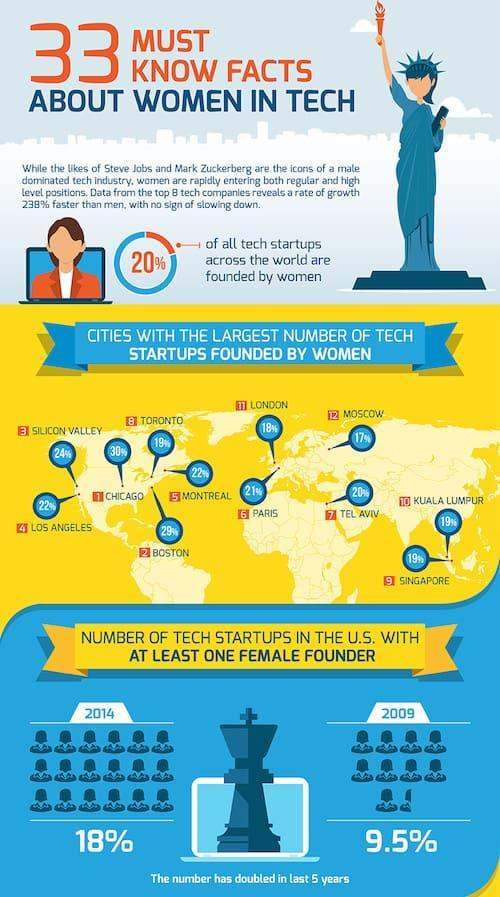What percentage of tech startups in the U.S. has at least one female founder in 2009?
Answer the question with a short phrase. 9.5% What percentage of tech startups in the U.S. has at least one female founder in 2014? 18% What is the number of tech startups founded by women in Singapore? 9 What is the number of tech startups founded by women in Toronto? 8 What percentage of tech startups were founded by women in London? 18% What percentage of tech startups were founded by women in Boston? 29% 